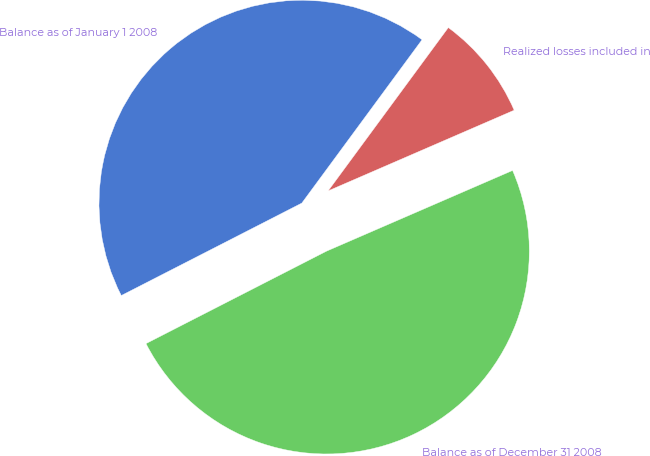Convert chart to OTSL. <chart><loc_0><loc_0><loc_500><loc_500><pie_chart><fcel>Balance as of January 1 2008<fcel>Balance as of December 31 2008<fcel>Realized losses included in<nl><fcel>42.63%<fcel>48.98%<fcel>8.39%<nl></chart> 